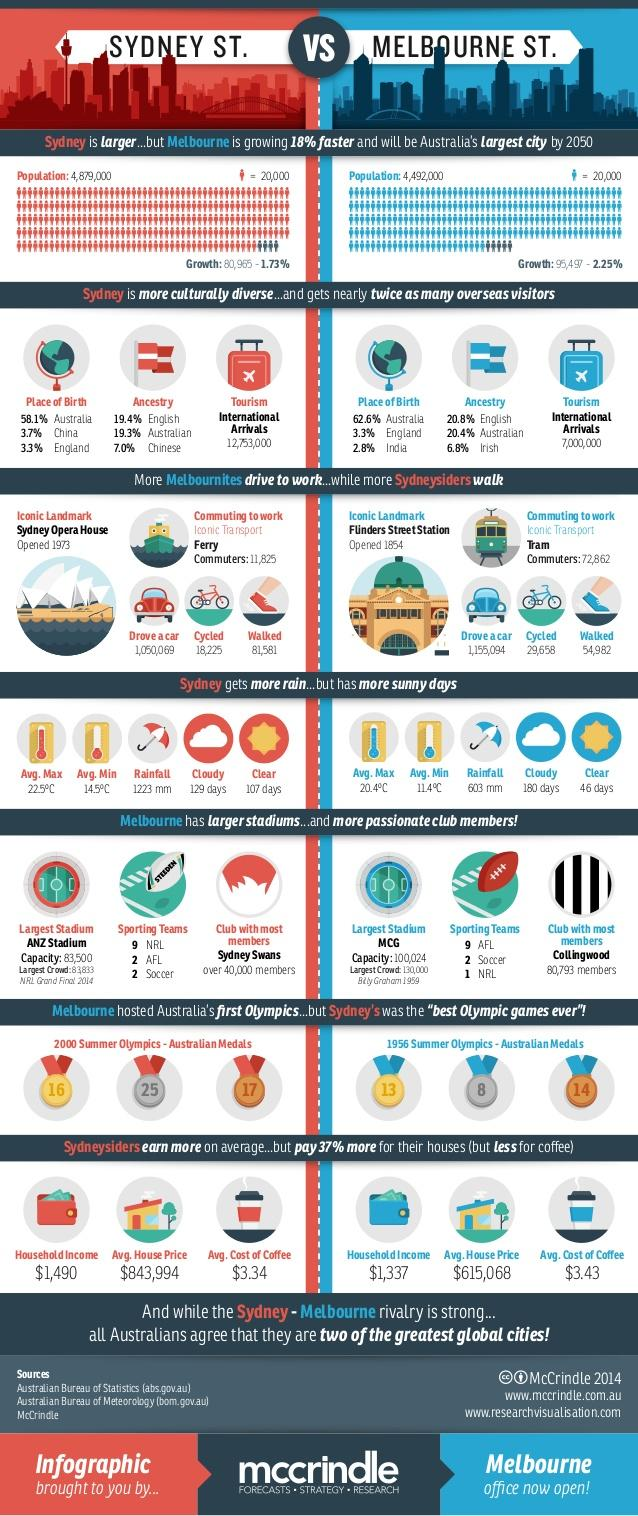Highlight a few significant elements in this photo. The total population of Melbourne is approximately 4,492,000. The Sydney Opera House is the major attraction in Sydney, drawing visitors from around the world with its iconic design and world-renowned performances. In Melbourne, approximately 54,982 people commute to work by walking. The average household income in Sydney is estimated to be $1,490 per month. The average house price in Sydney is $843,994. 